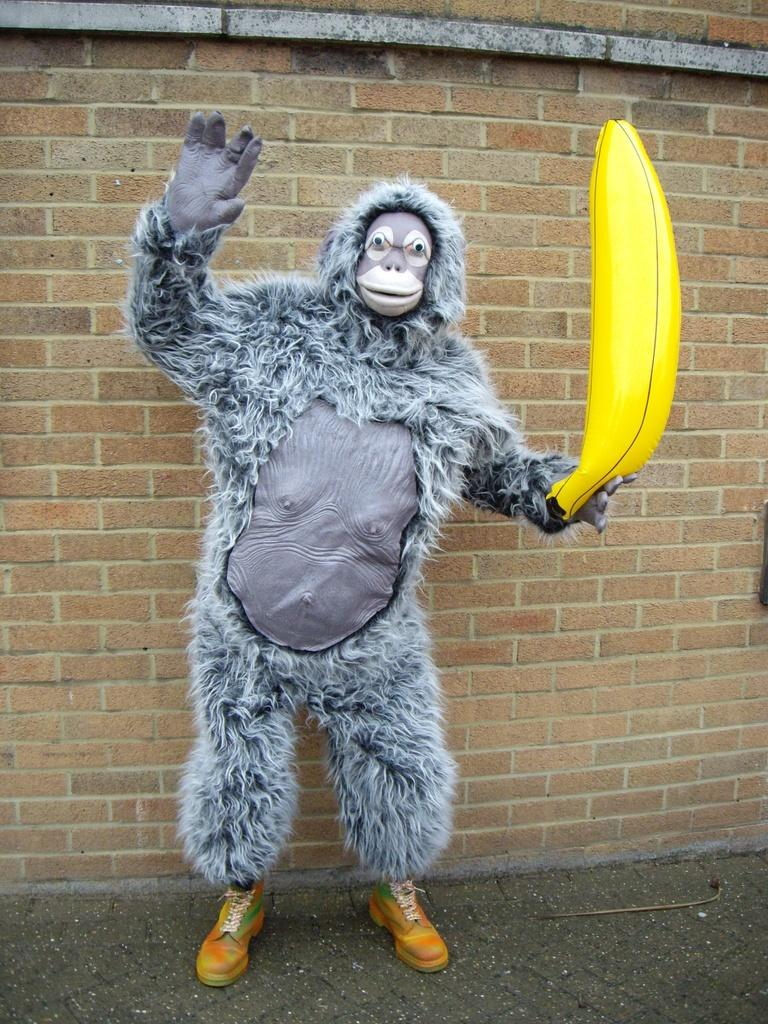Who or what can be seen in the image? There is a person in the image. What is the person wearing? The person is wearing a costume. What can be seen in the background of the image? There is a wall visible in the background of the image. Can you see any sail or island in the image? No, there is no sail or island present in the image. 